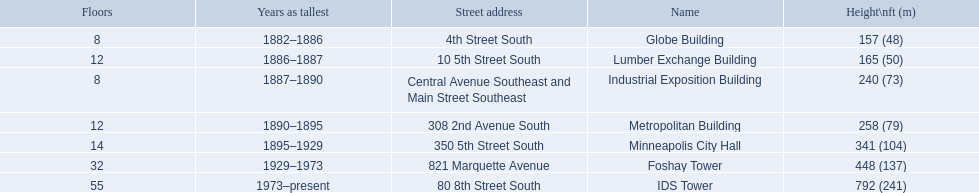What years was 240 ft considered tall? 1887–1890. What building held this record? Industrial Exposition Building. What are the heights of the buildings? 157 (48), 165 (50), 240 (73), 258 (79), 341 (104), 448 (137), 792 (241). What building is 240 ft tall? Industrial Exposition Building. 